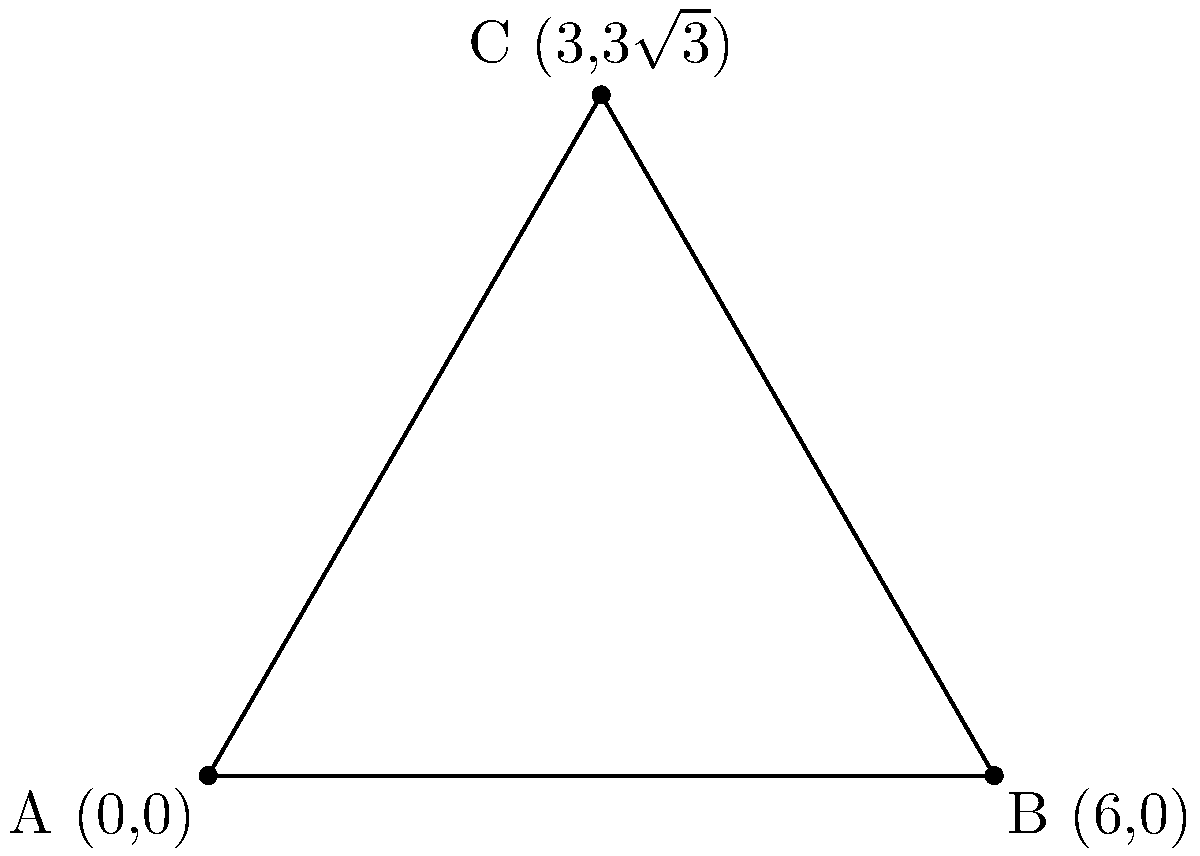As a senior iOS developer, you're mentoring a junior developer who is working on a geometry-based feature. To help them understand coordinate geometry better, you decide to create an exercise. Given two points A(0,0) and B(6,0), what are the coordinates of point C that forms an equilateral triangle with A and B? Let's approach this step-by-step:

1) In an equilateral triangle, all sides are equal and all angles are 60°.

2) The base of the triangle is formed by points A and B. The length of AB is 6 units.

3) The x-coordinate of C will be the midpoint of AB:
   $x_C = \frac{x_A + x_B}{2} = \frac{0 + 6}{2} = 3$

4) To find the y-coordinate, we can use the 30-60-90 triangle rule:
   In a 30-60-90 triangle, if the shortest side (opposite to 30°) is x, then the hypotenuse is 2x, and the remaining side is $x\sqrt{3}$.

5) Half of our equilateral triangle forms a 30-60-90 triangle. The base of this triangle is 3 (half of AB).

6) Therefore, the height of the equilateral triangle (y-coordinate of C) will be:
   $y_C = 3\sqrt{3}$

7) Thus, the coordinates of point C are (3, $3\sqrt{3}$).

This approach demonstrates how to apply geometric principles to solve coordinate problems, which is valuable in many programming scenarios, including iOS development for graphics or game features.
Answer: C(3, $3\sqrt{3}$) 